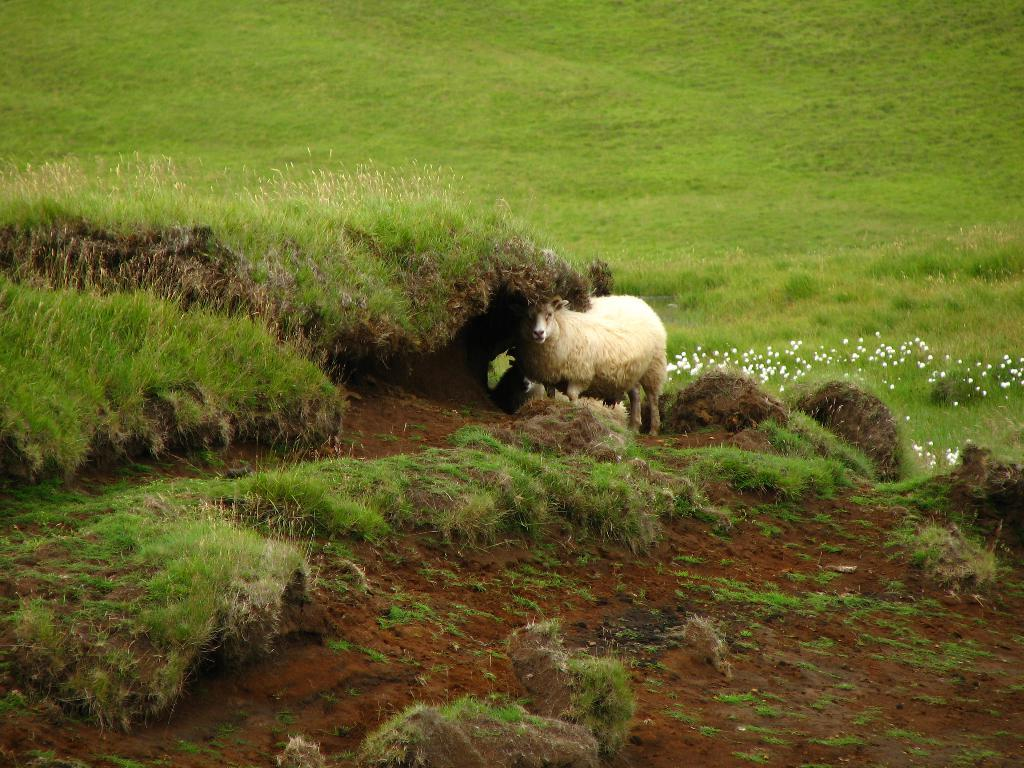What type of animal is in the image? There is a sheep in the image. What is the sheep's position in relation to the ground? The sheep is standing on the ground. What is the ground covered with? The ground is covered with grass and mud. What type of garden can be seen in the image? There is no garden present in the image; it features a sheep standing on grass- and mud-covered ground. How many rifles are visible in the image? There are no rifles present in the image. 